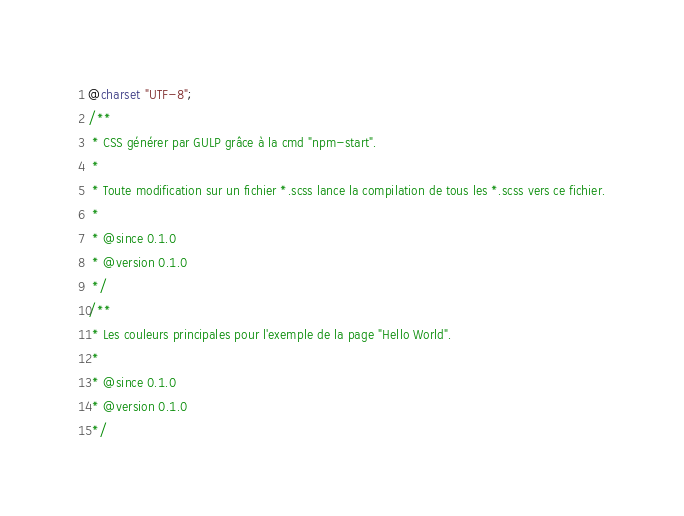<code> <loc_0><loc_0><loc_500><loc_500><_CSS_>@charset "UTF-8";
/**
 * CSS générer par GULP grâce à la cmd "npm-start".
 *
 * Toute modification sur un fichier *.scss lance la compilation de tous les *.scss vers ce fichier.
 *
 * @since 0.1.0
 * @version 0.1.0
 */
/**
 * Les couleurs principales pour l'exemple de la page "Hello World".
 *
 * @since 0.1.0
 * @version 0.1.0
 */
</code> 